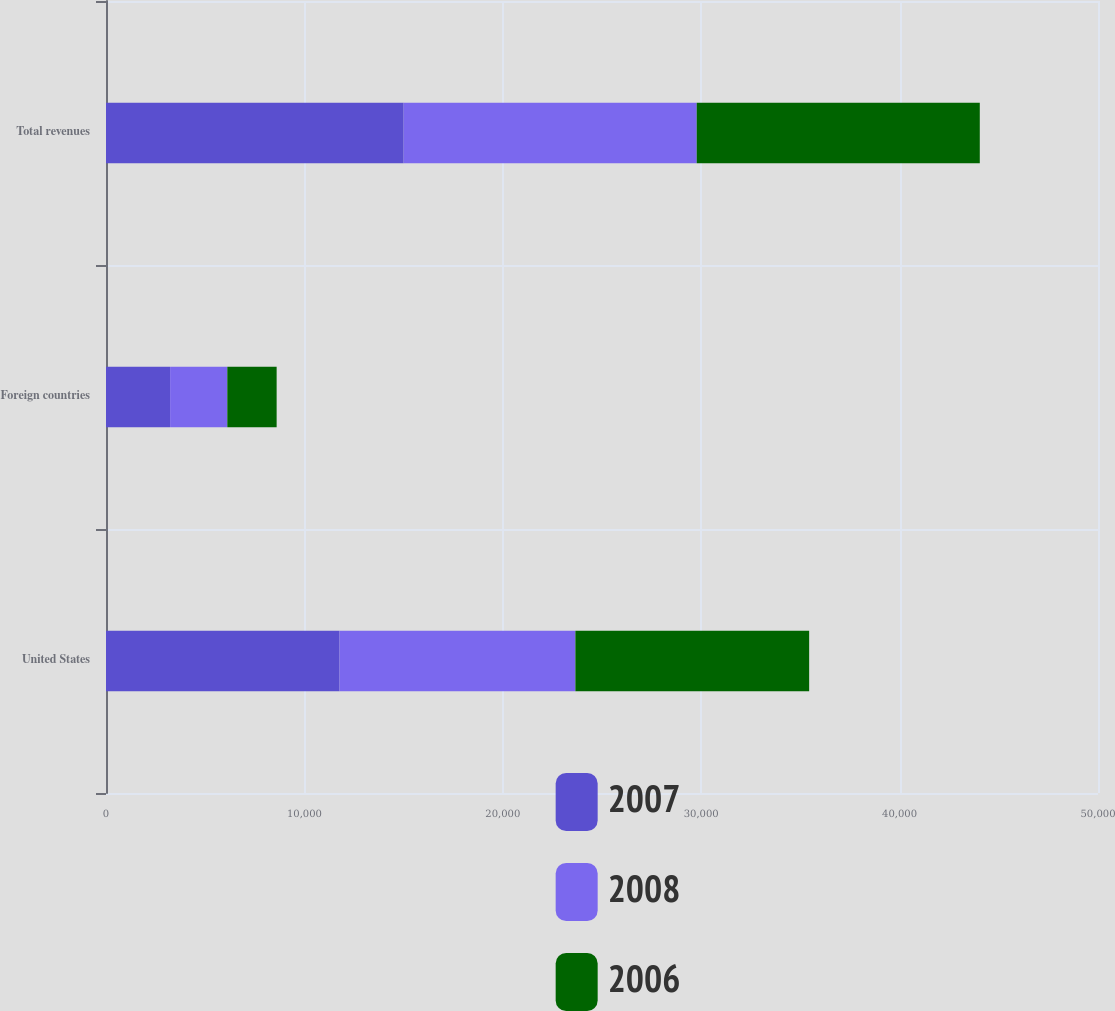<chart> <loc_0><loc_0><loc_500><loc_500><stacked_bar_chart><ecel><fcel>United States<fcel>Foreign countries<fcel>Total revenues<nl><fcel>2007<fcel>11772<fcel>3231<fcel>15003<nl><fcel>2008<fcel>11887<fcel>2884<fcel>14771<nl><fcel>2006<fcel>11782<fcel>2486<fcel>14268<nl></chart> 